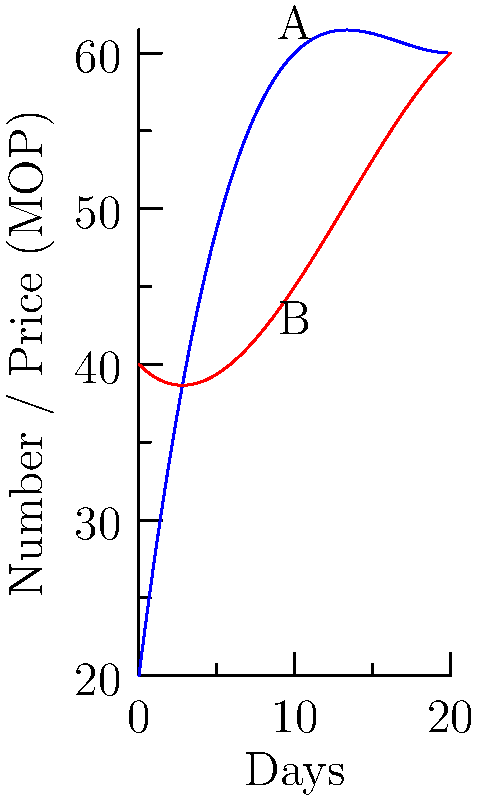In a Macau casino-hotel complex, the blue curve represents daily casino visitor numbers (in hundreds), and the red curve shows average daily hotel room prices (in MOP) over a 20-day period. At the point where the curves intersect, what is the approximate difference between the number of casino visitors and the hotel room price? To solve this problem, we need to follow these steps:

1. Identify the intersection point of the two curves. This occurs around day 10 on the x-axis.

2. At this intersection point:
   - Point A represents the number of casino visitors (blue curve)
   - Point B represents the hotel room price (red curve)

3. The y-value at this intersection is approximately 60.

4. Since the blue curve (casino visitors) is measured in hundreds:
   60 on the y-axis for the blue curve represents 6000 visitors

5. The red curve (hotel room prices) is in MOP, so:
   60 on the y-axis for the red curve represents 60 MOP

6. Calculate the difference:
   6000 (visitors) - 60 (MOP) = 5940

Therefore, the approximate difference between the number of casino visitors and the hotel room price at the intersection point is 5940.
Answer: 5940 